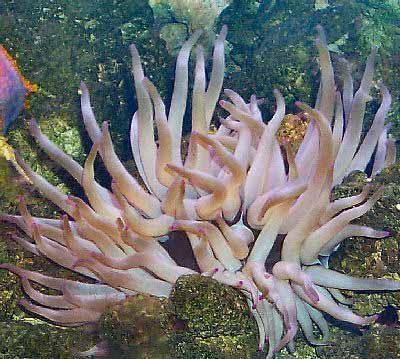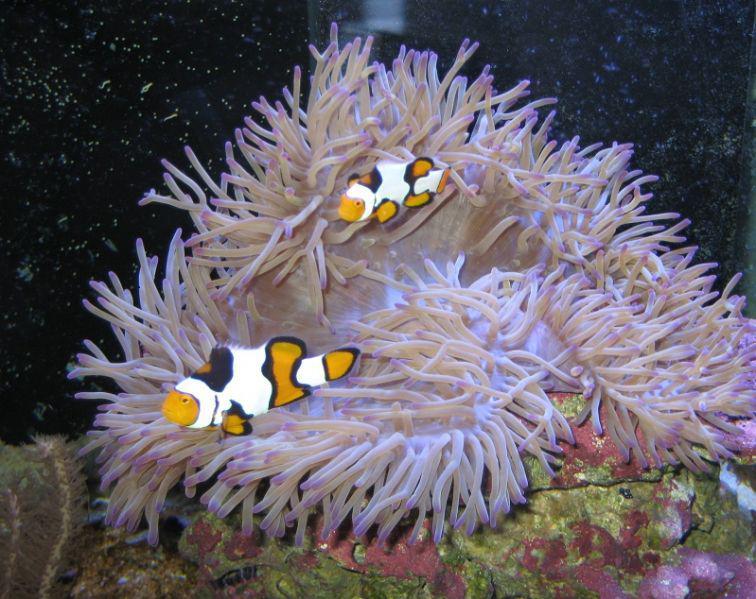The first image is the image on the left, the second image is the image on the right. Evaluate the accuracy of this statement regarding the images: "There are purple dots covering the end of the coral reef’s individual arms.". Is it true? Answer yes or no. No. 